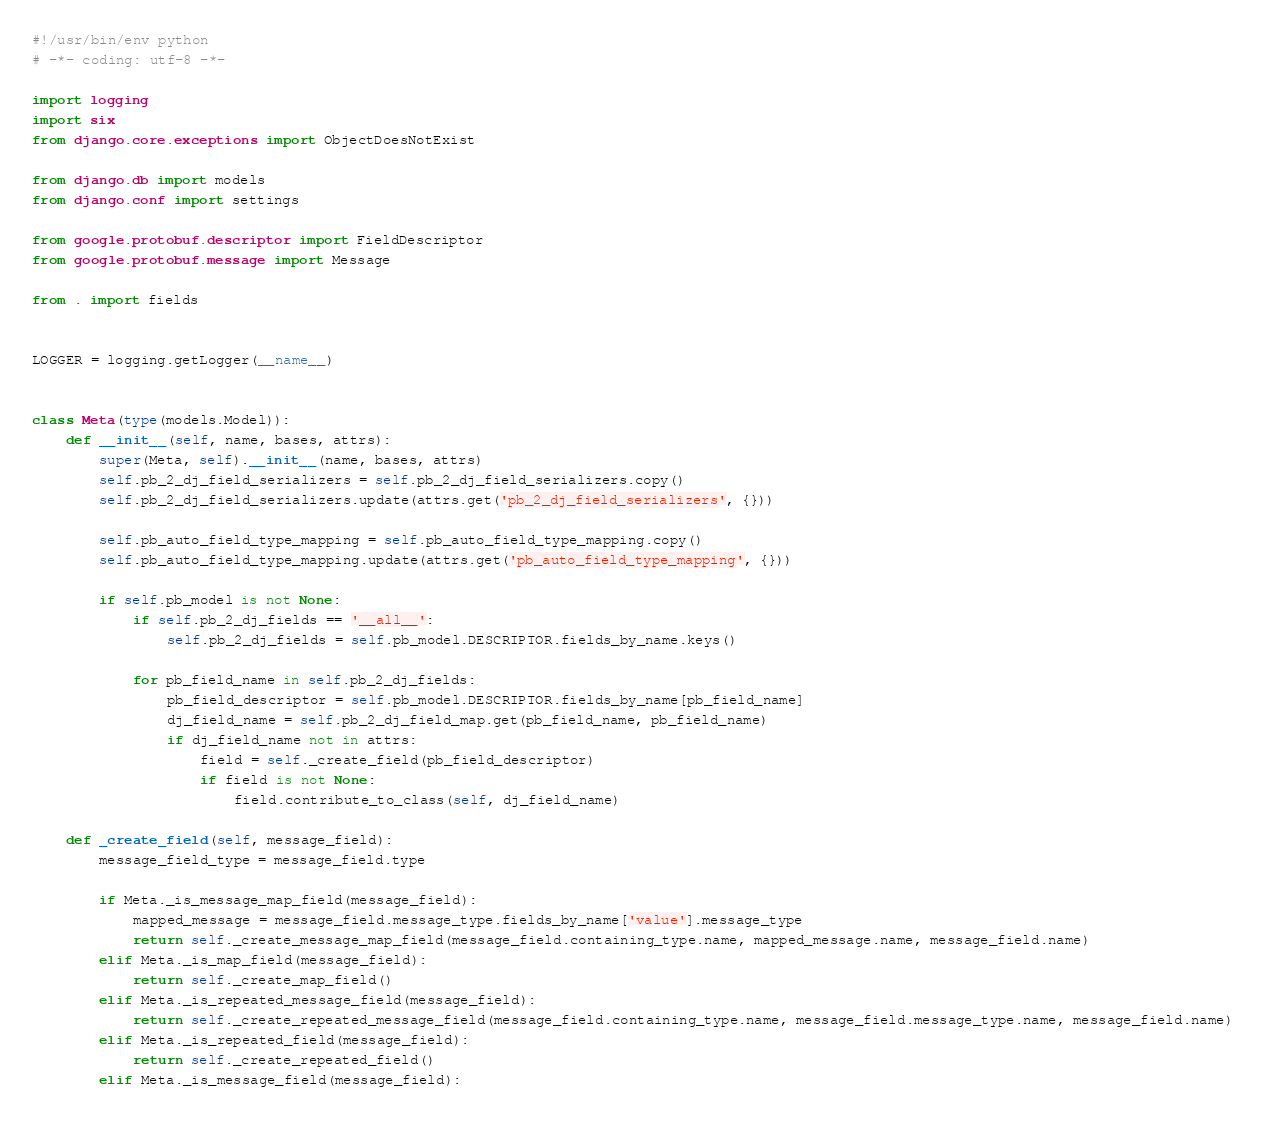<code> <loc_0><loc_0><loc_500><loc_500><_Python_>#!/usr/bin/env python
# -*- coding: utf-8 -*-

import logging
import six
from django.core.exceptions import ObjectDoesNotExist

from django.db import models
from django.conf import settings

from google.protobuf.descriptor import FieldDescriptor
from google.protobuf.message import Message

from . import fields


LOGGER = logging.getLogger(__name__)


class Meta(type(models.Model)):
    def __init__(self, name, bases, attrs):
        super(Meta, self).__init__(name, bases, attrs)
        self.pb_2_dj_field_serializers = self.pb_2_dj_field_serializers.copy()
        self.pb_2_dj_field_serializers.update(attrs.get('pb_2_dj_field_serializers', {}))

        self.pb_auto_field_type_mapping = self.pb_auto_field_type_mapping.copy()
        self.pb_auto_field_type_mapping.update(attrs.get('pb_auto_field_type_mapping', {}))

        if self.pb_model is not None:
            if self.pb_2_dj_fields == '__all__':
                self.pb_2_dj_fields = self.pb_model.DESCRIPTOR.fields_by_name.keys()

            for pb_field_name in self.pb_2_dj_fields:
                pb_field_descriptor = self.pb_model.DESCRIPTOR.fields_by_name[pb_field_name]
                dj_field_name = self.pb_2_dj_field_map.get(pb_field_name, pb_field_name)
                if dj_field_name not in attrs:
                    field = self._create_field(pb_field_descriptor)
                    if field is not None:
                        field.contribute_to_class(self, dj_field_name)

    def _create_field(self, message_field):
        message_field_type = message_field.type

        if Meta._is_message_map_field(message_field):
            mapped_message = message_field.message_type.fields_by_name['value'].message_type
            return self._create_message_map_field(message_field.containing_type.name, mapped_message.name, message_field.name)
        elif Meta._is_map_field(message_field):
            return self._create_map_field()
        elif Meta._is_repeated_message_field(message_field):
            return self._create_repeated_message_field(message_field.containing_type.name, message_field.message_type.name, message_field.name)
        elif Meta._is_repeated_field(message_field):
            return self._create_repeated_field()
        elif Meta._is_message_field(message_field):</code> 